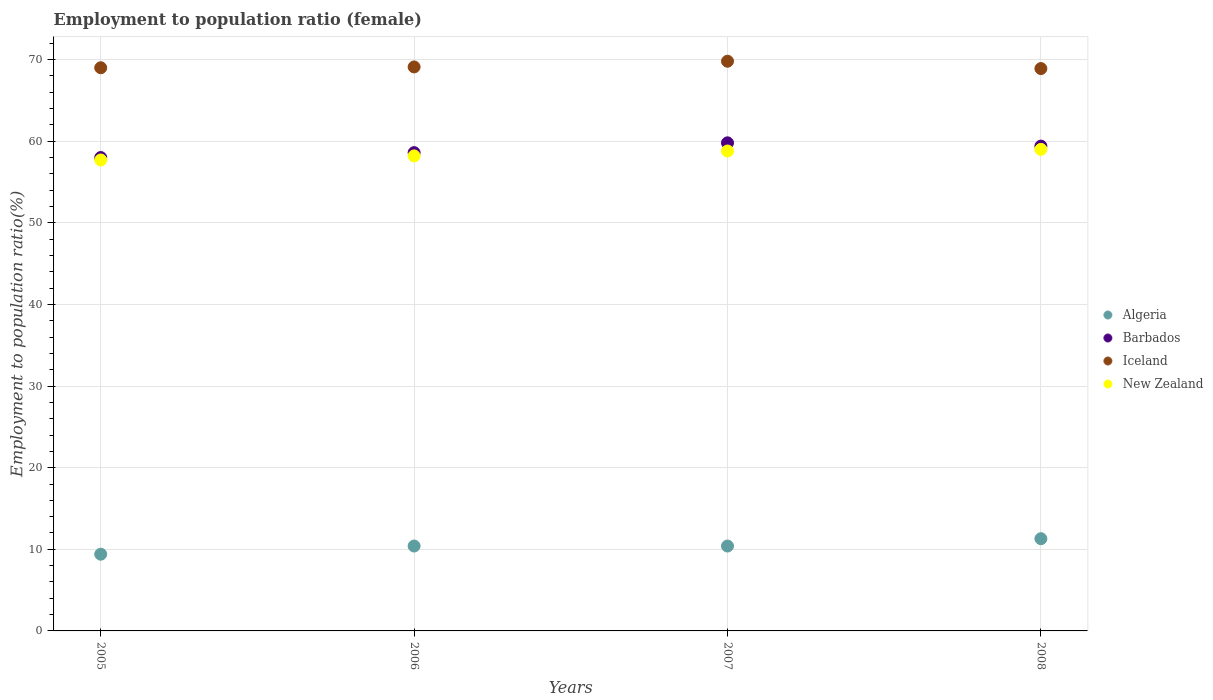How many different coloured dotlines are there?
Provide a succinct answer. 4. What is the employment to population ratio in Algeria in 2005?
Your answer should be very brief. 9.4. Across all years, what is the maximum employment to population ratio in Barbados?
Ensure brevity in your answer.  59.8. Across all years, what is the minimum employment to population ratio in Iceland?
Offer a very short reply. 68.9. In which year was the employment to population ratio in New Zealand maximum?
Your answer should be very brief. 2008. In which year was the employment to population ratio in Algeria minimum?
Your response must be concise. 2005. What is the total employment to population ratio in Barbados in the graph?
Your answer should be very brief. 235.8. What is the difference between the employment to population ratio in Algeria in 2007 and the employment to population ratio in New Zealand in 2008?
Keep it short and to the point. -48.6. What is the average employment to population ratio in Barbados per year?
Offer a very short reply. 58.95. In the year 2008, what is the difference between the employment to population ratio in Iceland and employment to population ratio in New Zealand?
Offer a very short reply. 9.9. What is the ratio of the employment to population ratio in New Zealand in 2005 to that in 2006?
Provide a succinct answer. 0.99. What is the difference between the highest and the second highest employment to population ratio in Barbados?
Give a very brief answer. 0.4. What is the difference between the highest and the lowest employment to population ratio in Algeria?
Provide a short and direct response. 1.9. In how many years, is the employment to population ratio in New Zealand greater than the average employment to population ratio in New Zealand taken over all years?
Give a very brief answer. 2. Is it the case that in every year, the sum of the employment to population ratio in New Zealand and employment to population ratio in Algeria  is greater than the employment to population ratio in Iceland?
Your answer should be very brief. No. Does the employment to population ratio in Algeria monotonically increase over the years?
Offer a terse response. No. Is the employment to population ratio in New Zealand strictly greater than the employment to population ratio in Iceland over the years?
Provide a succinct answer. No. Is the employment to population ratio in Barbados strictly less than the employment to population ratio in Iceland over the years?
Ensure brevity in your answer.  Yes. What is the difference between two consecutive major ticks on the Y-axis?
Your answer should be very brief. 10. Are the values on the major ticks of Y-axis written in scientific E-notation?
Offer a very short reply. No. Does the graph contain grids?
Provide a succinct answer. Yes. Where does the legend appear in the graph?
Make the answer very short. Center right. What is the title of the graph?
Your answer should be compact. Employment to population ratio (female). What is the Employment to population ratio(%) in Algeria in 2005?
Your answer should be very brief. 9.4. What is the Employment to population ratio(%) in Barbados in 2005?
Give a very brief answer. 58. What is the Employment to population ratio(%) in New Zealand in 2005?
Make the answer very short. 57.7. What is the Employment to population ratio(%) in Algeria in 2006?
Your answer should be compact. 10.4. What is the Employment to population ratio(%) of Barbados in 2006?
Ensure brevity in your answer.  58.6. What is the Employment to population ratio(%) of Iceland in 2006?
Give a very brief answer. 69.1. What is the Employment to population ratio(%) of New Zealand in 2006?
Ensure brevity in your answer.  58.2. What is the Employment to population ratio(%) of Algeria in 2007?
Offer a very short reply. 10.4. What is the Employment to population ratio(%) in Barbados in 2007?
Your answer should be compact. 59.8. What is the Employment to population ratio(%) of Iceland in 2007?
Provide a succinct answer. 69.8. What is the Employment to population ratio(%) in New Zealand in 2007?
Offer a terse response. 58.8. What is the Employment to population ratio(%) of Algeria in 2008?
Your answer should be very brief. 11.3. What is the Employment to population ratio(%) in Barbados in 2008?
Ensure brevity in your answer.  59.4. What is the Employment to population ratio(%) of Iceland in 2008?
Make the answer very short. 68.9. Across all years, what is the maximum Employment to population ratio(%) in Algeria?
Your response must be concise. 11.3. Across all years, what is the maximum Employment to population ratio(%) in Barbados?
Keep it short and to the point. 59.8. Across all years, what is the maximum Employment to population ratio(%) of Iceland?
Offer a very short reply. 69.8. Across all years, what is the maximum Employment to population ratio(%) in New Zealand?
Ensure brevity in your answer.  59. Across all years, what is the minimum Employment to population ratio(%) of Algeria?
Offer a terse response. 9.4. Across all years, what is the minimum Employment to population ratio(%) in Barbados?
Keep it short and to the point. 58. Across all years, what is the minimum Employment to population ratio(%) of Iceland?
Give a very brief answer. 68.9. Across all years, what is the minimum Employment to population ratio(%) of New Zealand?
Ensure brevity in your answer.  57.7. What is the total Employment to population ratio(%) in Algeria in the graph?
Your answer should be very brief. 41.5. What is the total Employment to population ratio(%) in Barbados in the graph?
Ensure brevity in your answer.  235.8. What is the total Employment to population ratio(%) of Iceland in the graph?
Provide a succinct answer. 276.8. What is the total Employment to population ratio(%) in New Zealand in the graph?
Keep it short and to the point. 233.7. What is the difference between the Employment to population ratio(%) of Algeria in 2005 and that in 2006?
Your answer should be compact. -1. What is the difference between the Employment to population ratio(%) in Barbados in 2005 and that in 2006?
Offer a terse response. -0.6. What is the difference between the Employment to population ratio(%) of Iceland in 2005 and that in 2006?
Give a very brief answer. -0.1. What is the difference between the Employment to population ratio(%) in New Zealand in 2005 and that in 2006?
Your answer should be compact. -0.5. What is the difference between the Employment to population ratio(%) in Algeria in 2005 and that in 2007?
Offer a very short reply. -1. What is the difference between the Employment to population ratio(%) in Iceland in 2005 and that in 2007?
Your response must be concise. -0.8. What is the difference between the Employment to population ratio(%) of Barbados in 2005 and that in 2008?
Offer a very short reply. -1.4. What is the difference between the Employment to population ratio(%) of Iceland in 2005 and that in 2008?
Your response must be concise. 0.1. What is the difference between the Employment to population ratio(%) of New Zealand in 2005 and that in 2008?
Make the answer very short. -1.3. What is the difference between the Employment to population ratio(%) in Barbados in 2006 and that in 2007?
Your answer should be very brief. -1.2. What is the difference between the Employment to population ratio(%) of Barbados in 2006 and that in 2008?
Your response must be concise. -0.8. What is the difference between the Employment to population ratio(%) in Iceland in 2006 and that in 2008?
Your answer should be very brief. 0.2. What is the difference between the Employment to population ratio(%) of New Zealand in 2006 and that in 2008?
Provide a short and direct response. -0.8. What is the difference between the Employment to population ratio(%) of Iceland in 2007 and that in 2008?
Offer a very short reply. 0.9. What is the difference between the Employment to population ratio(%) in Algeria in 2005 and the Employment to population ratio(%) in Barbados in 2006?
Your response must be concise. -49.2. What is the difference between the Employment to population ratio(%) in Algeria in 2005 and the Employment to population ratio(%) in Iceland in 2006?
Your answer should be very brief. -59.7. What is the difference between the Employment to population ratio(%) in Algeria in 2005 and the Employment to population ratio(%) in New Zealand in 2006?
Offer a terse response. -48.8. What is the difference between the Employment to population ratio(%) of Barbados in 2005 and the Employment to population ratio(%) of New Zealand in 2006?
Provide a short and direct response. -0.2. What is the difference between the Employment to population ratio(%) in Iceland in 2005 and the Employment to population ratio(%) in New Zealand in 2006?
Your response must be concise. 10.8. What is the difference between the Employment to population ratio(%) of Algeria in 2005 and the Employment to population ratio(%) of Barbados in 2007?
Offer a terse response. -50.4. What is the difference between the Employment to population ratio(%) in Algeria in 2005 and the Employment to population ratio(%) in Iceland in 2007?
Give a very brief answer. -60.4. What is the difference between the Employment to population ratio(%) of Algeria in 2005 and the Employment to population ratio(%) of New Zealand in 2007?
Offer a very short reply. -49.4. What is the difference between the Employment to population ratio(%) in Barbados in 2005 and the Employment to population ratio(%) in Iceland in 2007?
Provide a short and direct response. -11.8. What is the difference between the Employment to population ratio(%) in Barbados in 2005 and the Employment to population ratio(%) in New Zealand in 2007?
Provide a short and direct response. -0.8. What is the difference between the Employment to population ratio(%) in Algeria in 2005 and the Employment to population ratio(%) in Iceland in 2008?
Offer a terse response. -59.5. What is the difference between the Employment to population ratio(%) of Algeria in 2005 and the Employment to population ratio(%) of New Zealand in 2008?
Give a very brief answer. -49.6. What is the difference between the Employment to population ratio(%) in Barbados in 2005 and the Employment to population ratio(%) in New Zealand in 2008?
Provide a succinct answer. -1. What is the difference between the Employment to population ratio(%) of Iceland in 2005 and the Employment to population ratio(%) of New Zealand in 2008?
Make the answer very short. 10. What is the difference between the Employment to population ratio(%) in Algeria in 2006 and the Employment to population ratio(%) in Barbados in 2007?
Provide a succinct answer. -49.4. What is the difference between the Employment to population ratio(%) of Algeria in 2006 and the Employment to population ratio(%) of Iceland in 2007?
Make the answer very short. -59.4. What is the difference between the Employment to population ratio(%) in Algeria in 2006 and the Employment to population ratio(%) in New Zealand in 2007?
Provide a short and direct response. -48.4. What is the difference between the Employment to population ratio(%) in Barbados in 2006 and the Employment to population ratio(%) in New Zealand in 2007?
Provide a succinct answer. -0.2. What is the difference between the Employment to population ratio(%) of Iceland in 2006 and the Employment to population ratio(%) of New Zealand in 2007?
Make the answer very short. 10.3. What is the difference between the Employment to population ratio(%) in Algeria in 2006 and the Employment to population ratio(%) in Barbados in 2008?
Your response must be concise. -49. What is the difference between the Employment to population ratio(%) of Algeria in 2006 and the Employment to population ratio(%) of Iceland in 2008?
Your answer should be compact. -58.5. What is the difference between the Employment to population ratio(%) in Algeria in 2006 and the Employment to population ratio(%) in New Zealand in 2008?
Provide a short and direct response. -48.6. What is the difference between the Employment to population ratio(%) in Algeria in 2007 and the Employment to population ratio(%) in Barbados in 2008?
Your response must be concise. -49. What is the difference between the Employment to population ratio(%) in Algeria in 2007 and the Employment to population ratio(%) in Iceland in 2008?
Give a very brief answer. -58.5. What is the difference between the Employment to population ratio(%) in Algeria in 2007 and the Employment to population ratio(%) in New Zealand in 2008?
Give a very brief answer. -48.6. What is the difference between the Employment to population ratio(%) in Barbados in 2007 and the Employment to population ratio(%) in Iceland in 2008?
Provide a succinct answer. -9.1. What is the difference between the Employment to population ratio(%) of Barbados in 2007 and the Employment to population ratio(%) of New Zealand in 2008?
Your response must be concise. 0.8. What is the difference between the Employment to population ratio(%) of Iceland in 2007 and the Employment to population ratio(%) of New Zealand in 2008?
Offer a terse response. 10.8. What is the average Employment to population ratio(%) of Algeria per year?
Give a very brief answer. 10.38. What is the average Employment to population ratio(%) of Barbados per year?
Your answer should be very brief. 58.95. What is the average Employment to population ratio(%) in Iceland per year?
Keep it short and to the point. 69.2. What is the average Employment to population ratio(%) of New Zealand per year?
Offer a very short reply. 58.42. In the year 2005, what is the difference between the Employment to population ratio(%) of Algeria and Employment to population ratio(%) of Barbados?
Your response must be concise. -48.6. In the year 2005, what is the difference between the Employment to population ratio(%) of Algeria and Employment to population ratio(%) of Iceland?
Offer a very short reply. -59.6. In the year 2005, what is the difference between the Employment to population ratio(%) of Algeria and Employment to population ratio(%) of New Zealand?
Your response must be concise. -48.3. In the year 2005, what is the difference between the Employment to population ratio(%) in Barbados and Employment to population ratio(%) in New Zealand?
Your answer should be very brief. 0.3. In the year 2006, what is the difference between the Employment to population ratio(%) in Algeria and Employment to population ratio(%) in Barbados?
Give a very brief answer. -48.2. In the year 2006, what is the difference between the Employment to population ratio(%) in Algeria and Employment to population ratio(%) in Iceland?
Give a very brief answer. -58.7. In the year 2006, what is the difference between the Employment to population ratio(%) in Algeria and Employment to population ratio(%) in New Zealand?
Ensure brevity in your answer.  -47.8. In the year 2006, what is the difference between the Employment to population ratio(%) of Iceland and Employment to population ratio(%) of New Zealand?
Offer a terse response. 10.9. In the year 2007, what is the difference between the Employment to population ratio(%) of Algeria and Employment to population ratio(%) of Barbados?
Offer a very short reply. -49.4. In the year 2007, what is the difference between the Employment to population ratio(%) of Algeria and Employment to population ratio(%) of Iceland?
Give a very brief answer. -59.4. In the year 2007, what is the difference between the Employment to population ratio(%) in Algeria and Employment to population ratio(%) in New Zealand?
Provide a succinct answer. -48.4. In the year 2007, what is the difference between the Employment to population ratio(%) of Iceland and Employment to population ratio(%) of New Zealand?
Make the answer very short. 11. In the year 2008, what is the difference between the Employment to population ratio(%) in Algeria and Employment to population ratio(%) in Barbados?
Make the answer very short. -48.1. In the year 2008, what is the difference between the Employment to population ratio(%) of Algeria and Employment to population ratio(%) of Iceland?
Ensure brevity in your answer.  -57.6. In the year 2008, what is the difference between the Employment to population ratio(%) in Algeria and Employment to population ratio(%) in New Zealand?
Provide a succinct answer. -47.7. In the year 2008, what is the difference between the Employment to population ratio(%) of Barbados and Employment to population ratio(%) of Iceland?
Keep it short and to the point. -9.5. In the year 2008, what is the difference between the Employment to population ratio(%) in Iceland and Employment to population ratio(%) in New Zealand?
Give a very brief answer. 9.9. What is the ratio of the Employment to population ratio(%) in Algeria in 2005 to that in 2006?
Provide a short and direct response. 0.9. What is the ratio of the Employment to population ratio(%) of Barbados in 2005 to that in 2006?
Provide a succinct answer. 0.99. What is the ratio of the Employment to population ratio(%) of Iceland in 2005 to that in 2006?
Your answer should be compact. 1. What is the ratio of the Employment to population ratio(%) in New Zealand in 2005 to that in 2006?
Your answer should be compact. 0.99. What is the ratio of the Employment to population ratio(%) of Algeria in 2005 to that in 2007?
Make the answer very short. 0.9. What is the ratio of the Employment to population ratio(%) of Barbados in 2005 to that in 2007?
Your answer should be compact. 0.97. What is the ratio of the Employment to population ratio(%) of New Zealand in 2005 to that in 2007?
Ensure brevity in your answer.  0.98. What is the ratio of the Employment to population ratio(%) in Algeria in 2005 to that in 2008?
Make the answer very short. 0.83. What is the ratio of the Employment to population ratio(%) in Barbados in 2005 to that in 2008?
Offer a very short reply. 0.98. What is the ratio of the Employment to population ratio(%) in Barbados in 2006 to that in 2007?
Offer a very short reply. 0.98. What is the ratio of the Employment to population ratio(%) in Algeria in 2006 to that in 2008?
Make the answer very short. 0.92. What is the ratio of the Employment to population ratio(%) of Barbados in 2006 to that in 2008?
Your answer should be compact. 0.99. What is the ratio of the Employment to population ratio(%) of New Zealand in 2006 to that in 2008?
Make the answer very short. 0.99. What is the ratio of the Employment to population ratio(%) of Algeria in 2007 to that in 2008?
Provide a short and direct response. 0.92. What is the ratio of the Employment to population ratio(%) in Iceland in 2007 to that in 2008?
Your answer should be compact. 1.01. What is the difference between the highest and the second highest Employment to population ratio(%) in Barbados?
Your answer should be very brief. 0.4. What is the difference between the highest and the second highest Employment to population ratio(%) of New Zealand?
Provide a short and direct response. 0.2. What is the difference between the highest and the lowest Employment to population ratio(%) in Iceland?
Your answer should be compact. 0.9. What is the difference between the highest and the lowest Employment to population ratio(%) in New Zealand?
Keep it short and to the point. 1.3. 